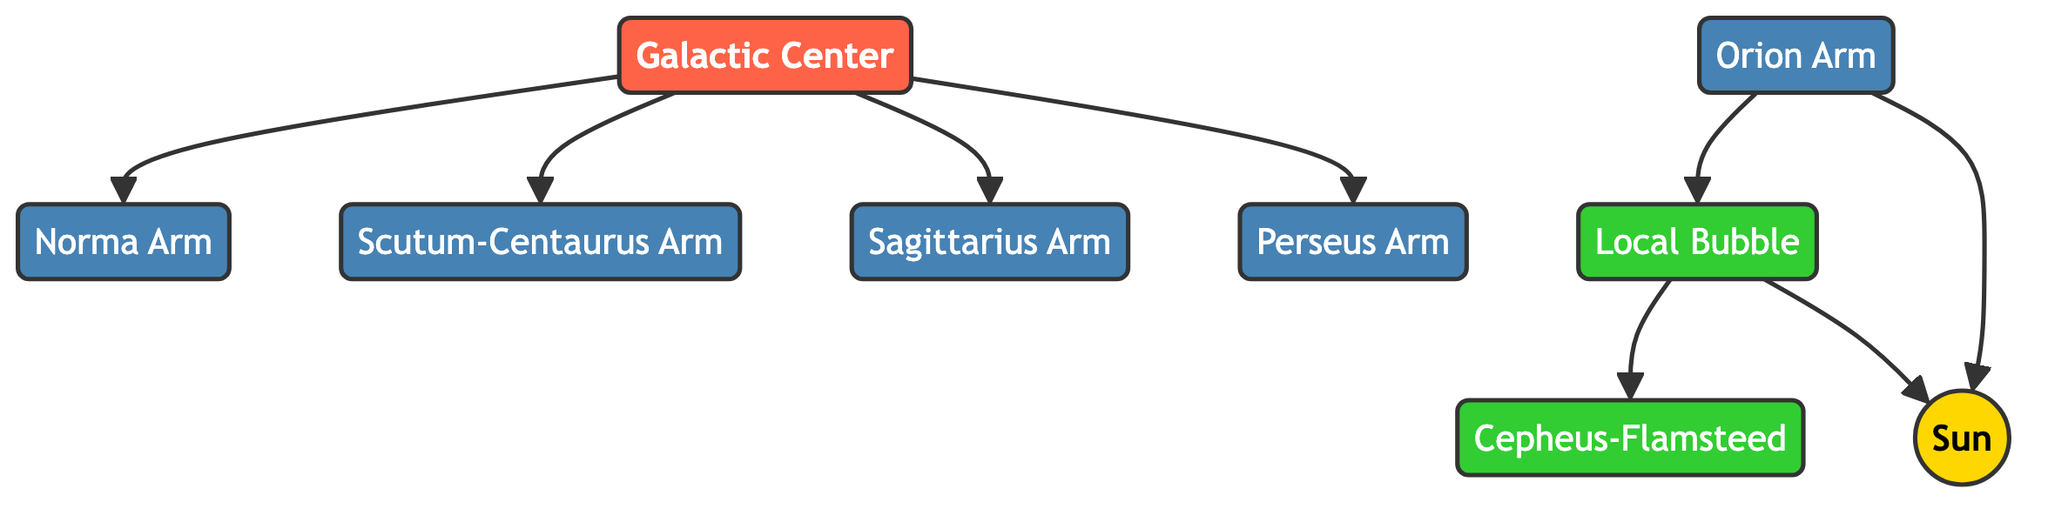What is the color associated with the Galactic Center? The Galactic Center is visually represented with a dark red color where the class definition specifies fill: #FF6347.
Answer: dark red How many spiral arms are illustrated in the diagram? There are five distinct spiral arms shown in the diagram: Norma Arm, Scutum-Centaurus Arm, Sagittarius Arm, Perseus Arm, and Orion Arm.
Answer: five Which arm is closest to the Sun? The Orion Arm is depicted nearest to the Sun, as indicated by the connections in the diagram.
Answer: Orion Arm From the Galactic Center, name the arm that is directly connected without any nodes in between. The Sagittarius Arm is connected directly to the Galactic Center (GC) without any intermediate nodes.
Answer: Sagittarius Arm How many local stellar neighborhoods are represented? There are three local stellar neighborhoods identified in the diagram: Local Bubble, Cepheus-Flamsteed, and the Sun.
Answer: three What connects the Local Bubble to the Sun? The diagram shows a direct connection where the Local Bubble leads to the Sun, illustrating their proximity in stellar neighborhoods.
Answer: Local Bubble Which arm has the most connections to the Galactic Center? The diagram indicates that the Galactic Center has connections to four different arms, making it the most connected to the four spiral arms: Norma, Scutum-Centaurus, Sagittarius, and Perseus.
Answer: Sagittarius Arm Is the Orion Arm part of the main spiral arms illustrated? Yes, the Orion Arm is one of the five primary spiral arms represented in the diagram.
Answer: Yes Which region does the Local Bubble connect to in addition to the Sun? The Local Bubble also connects to the Cepheus-Flamsteed neighborhood besides the Sun, as indicated by the arrows in the diagram.
Answer: Cepheus-Flamsteed 